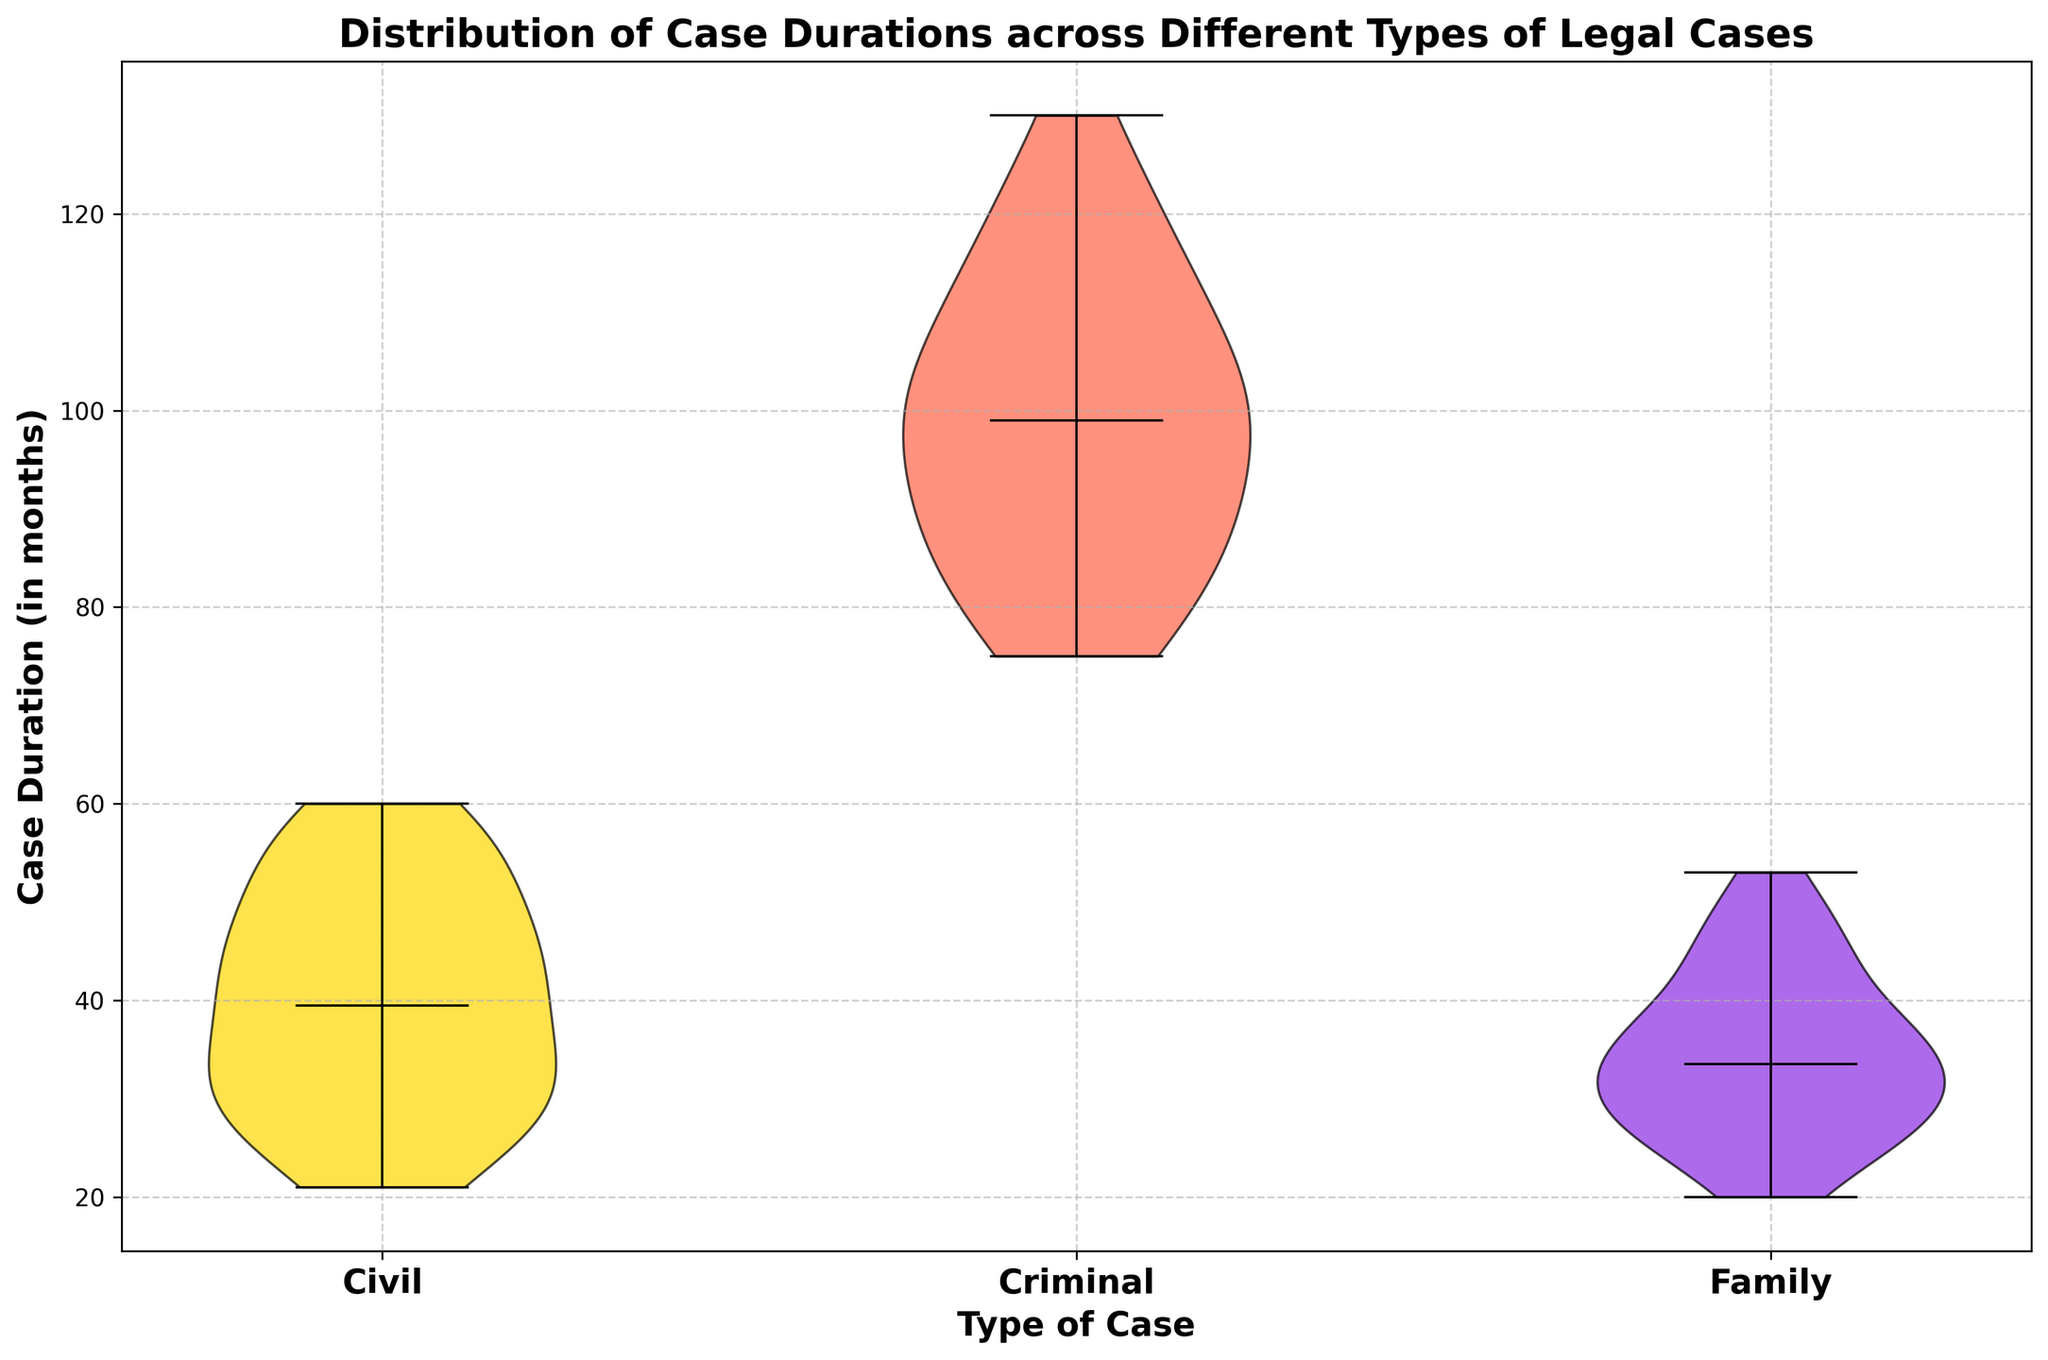What type of cases has the longest average duration? By observing the median lines in the violin plot and comparing their positions, we can infer which category has a higher duration typically. The criminal cases' median line is higher compared to civil and family cases.
Answer: Criminal Which case type shows the shortest median case duration? The violin plot's median line for family cases is visually lower compared to civil and criminal cases, indicating shorter durations.
Answer: Family Are there any case types that share a similar range in case durations? By observing the spread of the violins, civil and family cases have somewhat overlapping distributions and ranges, unlike criminal cases.
Answer: Civil and Family Which case type has the widest range of durations? The criminal cases' violin plot spans a broader vertical range from about 75 to 130 months, indicating a wider range.
Answer: Criminal Are the median durations generally higher in civil or family cases? By comparing the medians, we can see that civil cases' median is higher than family cases.
Answer: Civil How do the spread and skewness of criminal cases compare to civil cases? Criminal cases show a wider and more varied distribution with some visible skew towards higher durations, while civil cases are more concentrated and less spread out.
Answer: Criminal cases have wider spread and are more skewed Considering the upper extremes, which case type reaches higher durations? The upper edge of the criminal cases' violin plot goes higher compared to civil and family cases.
Answer: Criminal Which type of cases appears to have the most consistent durations? Family cases show a more narrow and consistent spread around their median line, unlike the more varied distributions in civil and criminal cases.
Answer: Family If you were to compare the lower extremes, which case type has the shortest recorded durations? The family cases' violin plot starts lower than civil and criminal cases, indicating the shortest durations.
Answer: Family Comparing the middle 50% (interquartile range) of case durations, which type of cases appears more widely spread out? The interquartile range for criminal cases is wider than civil and family cases as seen from the length of the central box of the violin plot.
Answer: Criminal 